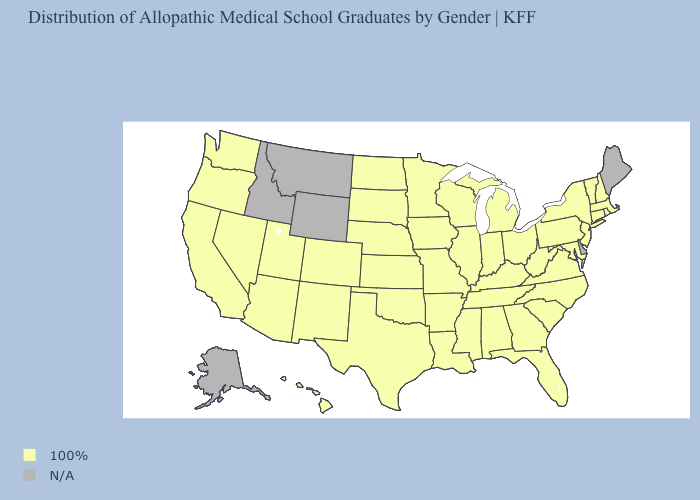What is the value of Florida?
Concise answer only. 100%. What is the lowest value in the USA?
Quick response, please. 100%. What is the value of South Dakota?
Answer briefly. 100%. What is the value of California?
Be succinct. 100%. Is the legend a continuous bar?
Be succinct. No. Which states have the lowest value in the USA?
Be succinct. Alabama, Arizona, Arkansas, California, Colorado, Connecticut, Florida, Georgia, Hawaii, Illinois, Indiana, Iowa, Kansas, Kentucky, Louisiana, Maryland, Massachusetts, Michigan, Minnesota, Mississippi, Missouri, Nebraska, Nevada, New Hampshire, New Jersey, New Mexico, New York, North Carolina, North Dakota, Ohio, Oklahoma, Oregon, Pennsylvania, Rhode Island, South Carolina, South Dakota, Tennessee, Texas, Utah, Vermont, Virginia, Washington, West Virginia, Wisconsin. Name the states that have a value in the range 100%?
Give a very brief answer. Alabama, Arizona, Arkansas, California, Colorado, Connecticut, Florida, Georgia, Hawaii, Illinois, Indiana, Iowa, Kansas, Kentucky, Louisiana, Maryland, Massachusetts, Michigan, Minnesota, Mississippi, Missouri, Nebraska, Nevada, New Hampshire, New Jersey, New Mexico, New York, North Carolina, North Dakota, Ohio, Oklahoma, Oregon, Pennsylvania, Rhode Island, South Carolina, South Dakota, Tennessee, Texas, Utah, Vermont, Virginia, Washington, West Virginia, Wisconsin. Which states have the highest value in the USA?
Short answer required. Alabama, Arizona, Arkansas, California, Colorado, Connecticut, Florida, Georgia, Hawaii, Illinois, Indiana, Iowa, Kansas, Kentucky, Louisiana, Maryland, Massachusetts, Michigan, Minnesota, Mississippi, Missouri, Nebraska, Nevada, New Hampshire, New Jersey, New Mexico, New York, North Carolina, North Dakota, Ohio, Oklahoma, Oregon, Pennsylvania, Rhode Island, South Carolina, South Dakota, Tennessee, Texas, Utah, Vermont, Virginia, Washington, West Virginia, Wisconsin. What is the value of Vermont?
Be succinct. 100%. What is the highest value in the South ?
Write a very short answer. 100%. Name the states that have a value in the range 100%?
Keep it brief. Alabama, Arizona, Arkansas, California, Colorado, Connecticut, Florida, Georgia, Hawaii, Illinois, Indiana, Iowa, Kansas, Kentucky, Louisiana, Maryland, Massachusetts, Michigan, Minnesota, Mississippi, Missouri, Nebraska, Nevada, New Hampshire, New Jersey, New Mexico, New York, North Carolina, North Dakota, Ohio, Oklahoma, Oregon, Pennsylvania, Rhode Island, South Carolina, South Dakota, Tennessee, Texas, Utah, Vermont, Virginia, Washington, West Virginia, Wisconsin. Name the states that have a value in the range N/A?
Quick response, please. Alaska, Delaware, Idaho, Maine, Montana, Wyoming. Does the first symbol in the legend represent the smallest category?
Quick response, please. No. 